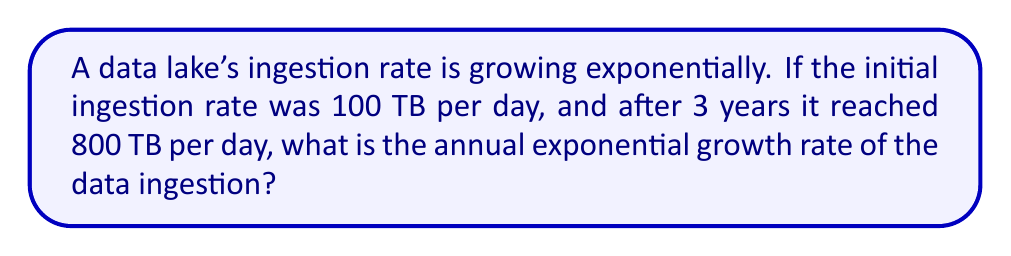Can you answer this question? Let's approach this step-by-step:

1) The exponential growth formula is:
   $$A = P(1 + r)^t$$
   Where:
   $A$ = Final amount
   $P$ = Initial amount
   $r$ = Annual growth rate
   $t$ = Time in years

2) We know:
   $P = 100$ TB/day
   $A = 800$ TB/day
   $t = 3$ years

3) Let's plug these into our formula:
   $$800 = 100(1 + r)^3$$

4) Divide both sides by 100:
   $$8 = (1 + r)^3$$

5) Take the cube root of both sides:
   $$\sqrt[3]{8} = 1 + r$$

6) Simplify:
   $$2 = 1 + r$$

7) Subtract 1 from both sides:
   $$r = 1$$

8) Convert to percentage:
   $$r = 100\%$$

Therefore, the annual exponential growth rate is 100%.
Answer: 100% 